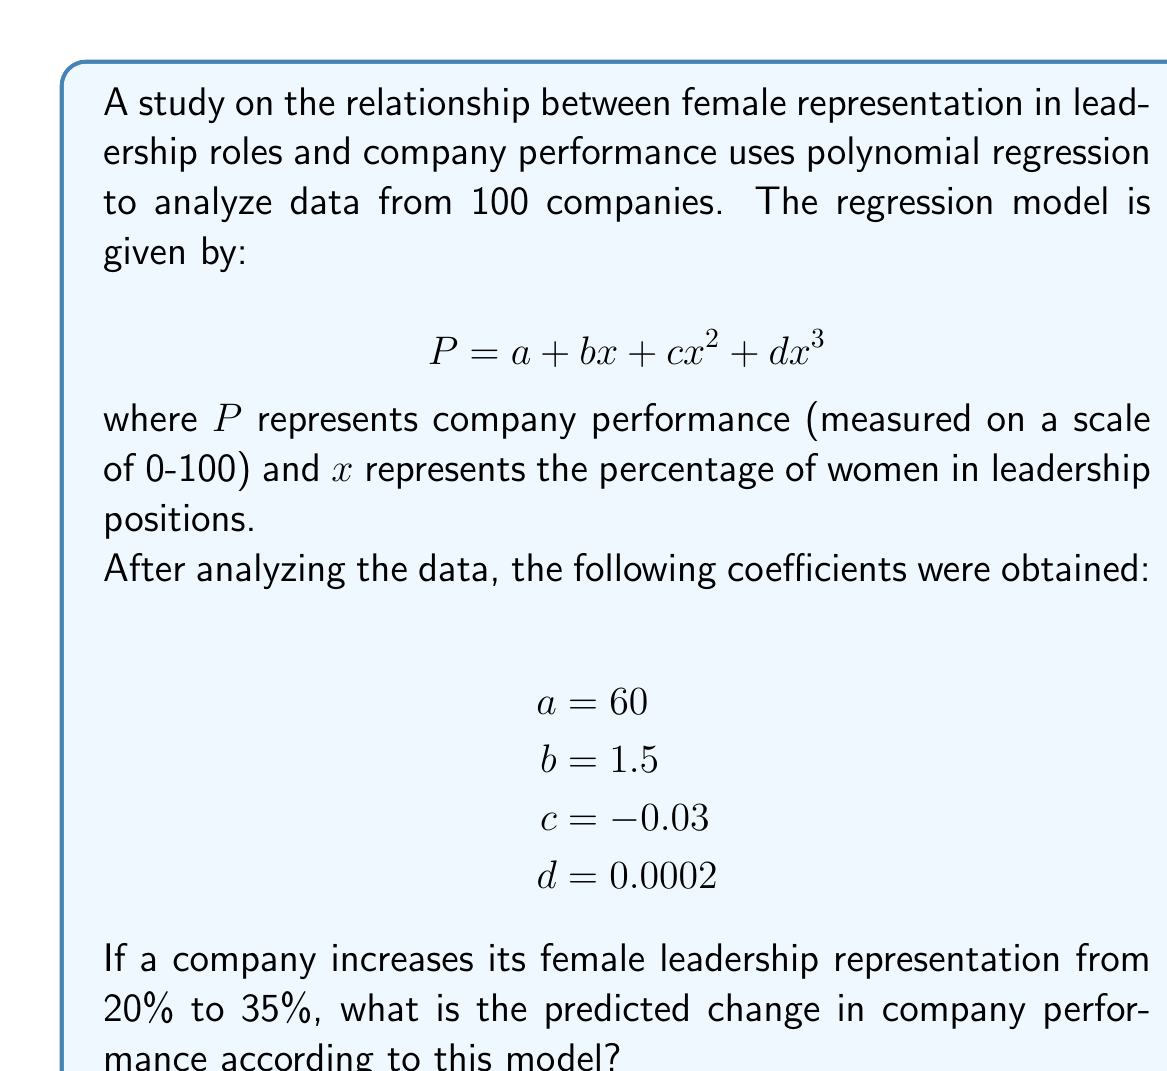What is the answer to this math problem? To solve this problem, we need to follow these steps:

1. Calculate the company performance for 20% female leadership representation.
2. Calculate the company performance for 35% female leadership representation.
3. Find the difference between these two values.

Let's start with the calculations:

1. For 20% female leadership (x = 20):
   $$P_{20} = 60 + 1.5(20) + (-0.03)(20^2) + 0.0002(20^3)$$
   $$P_{20} = 60 + 30 - 12 + 1.6$$
   $$P_{20} = 79.6$$

2. For 35% female leadership (x = 35):
   $$P_{35} = 60 + 1.5(35) + (-0.03)(35^2) + 0.0002(35^3)$$
   $$P_{35} = 60 + 52.5 - 36.75 + 8.575$$
   $$P_{35} = 84.325$$

3. The change in performance is:
   $$\Delta P = P_{35} - P_{20} = 84.325 - 79.6 = 4.725$$

Therefore, the predicted change in company performance when increasing female leadership representation from 20% to 35% is an increase of 4.725 points on the performance scale.
Answer: 4.725 